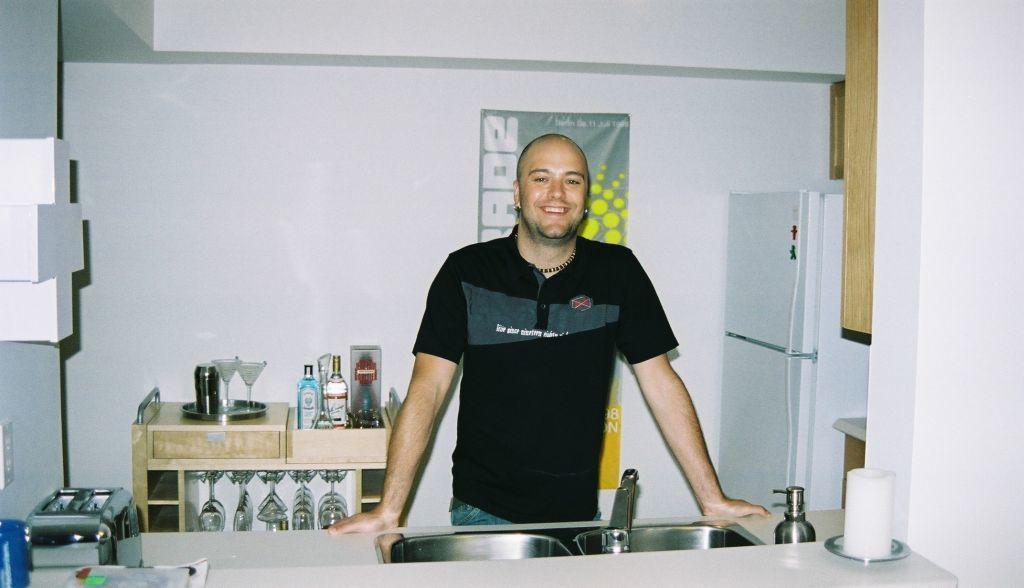Could you give a brief overview of what you see in this image? At the center of the image there is a person standing in front of the sink, which is on the kitchen platform. Behind him there is a table. On the table there are some objects placed. On the right side there is a refrigerator. In the background there is a wall. 